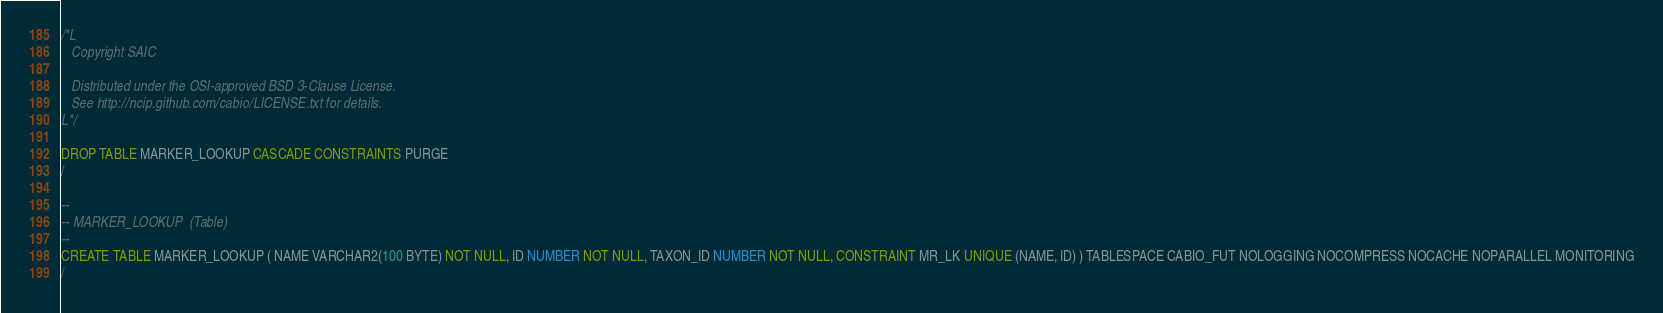Convert code to text. <code><loc_0><loc_0><loc_500><loc_500><_SQL_>/*L
   Copyright SAIC

   Distributed under the OSI-approved BSD 3-Clause License.
   See http://ncip.github.com/cabio/LICENSE.txt for details.
L*/

DROP TABLE MARKER_LOOKUP CASCADE CONSTRAINTS PURGE
/

--
-- MARKER_LOOKUP  (Table) 
--
CREATE TABLE MARKER_LOOKUP ( NAME VARCHAR2(100 BYTE) NOT NULL, ID NUMBER NOT NULL, TAXON_ID NUMBER NOT NULL, CONSTRAINT MR_LK UNIQUE (NAME, ID) ) TABLESPACE CABIO_FUT NOLOGGING NOCOMPRESS NOCACHE NOPARALLEL MONITORING
/


</code> 